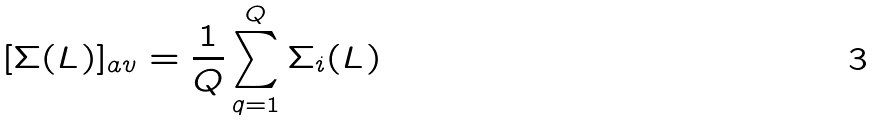Convert formula to latex. <formula><loc_0><loc_0><loc_500><loc_500>[ \Sigma ( L ) ] _ { a v } = \frac { 1 } { Q } \sum _ { q = 1 } ^ { Q } \Sigma _ { i } ( L )</formula> 